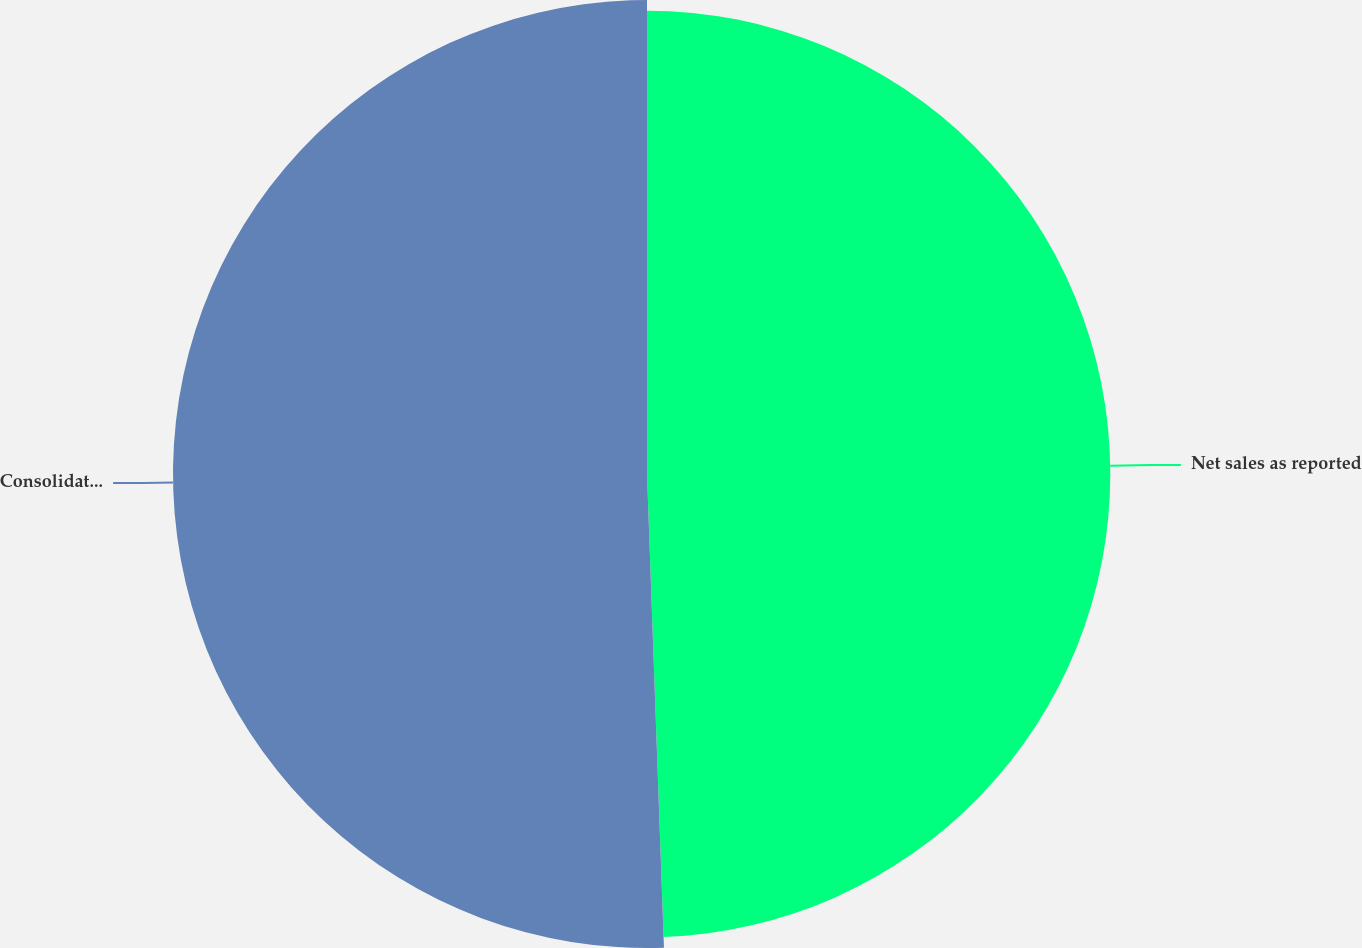Convert chart. <chart><loc_0><loc_0><loc_500><loc_500><pie_chart><fcel>Net sales as reported<fcel>Consolidated Net sales on a<nl><fcel>49.43%<fcel>50.57%<nl></chart> 